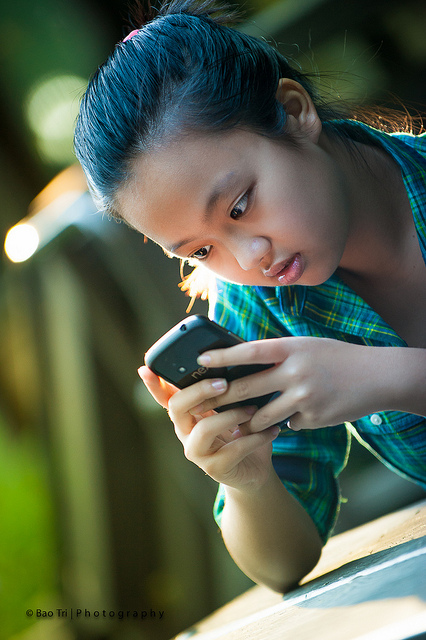Please transcribe the text in this image. Bao Photography 